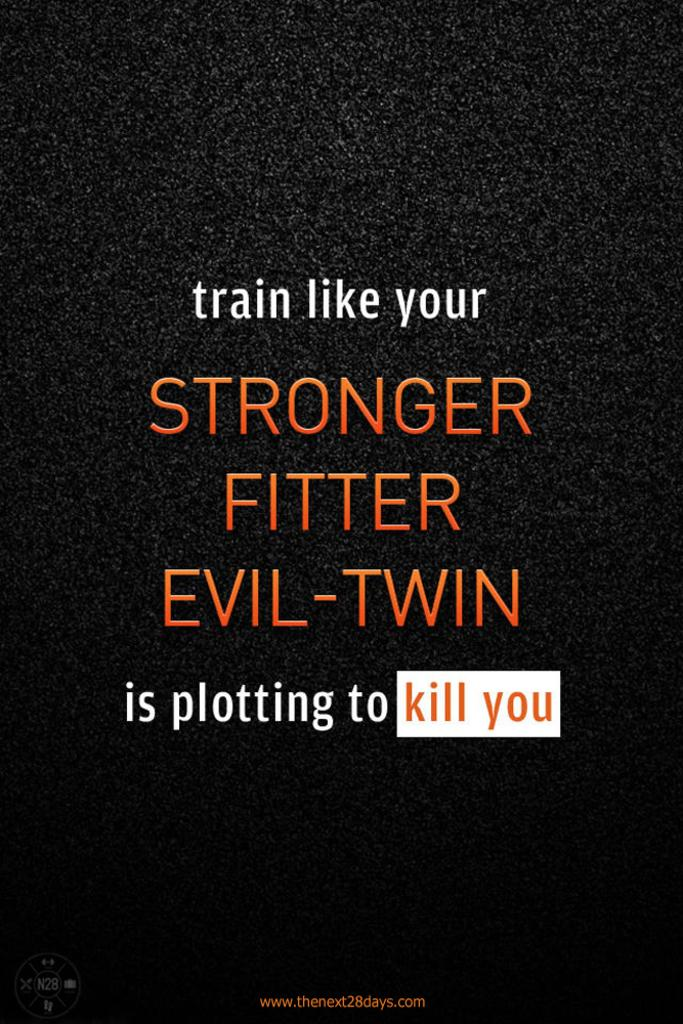<image>
Relay a brief, clear account of the picture shown. A black sign that says "train like your STRONGER FITTER EVIL-TWIN is plotting to kill you" 